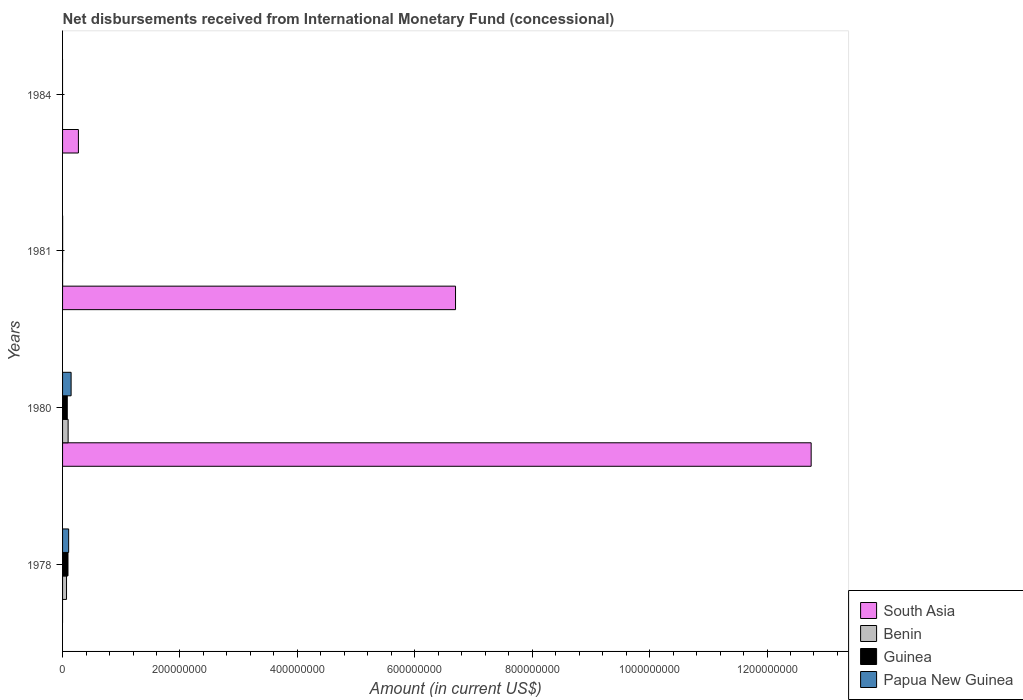How many different coloured bars are there?
Give a very brief answer. 4. Are the number of bars on each tick of the Y-axis equal?
Your response must be concise. No. How many bars are there on the 1st tick from the top?
Provide a succinct answer. 1. What is the label of the 3rd group of bars from the top?
Your answer should be very brief. 1980. In how many cases, is the number of bars for a given year not equal to the number of legend labels?
Your answer should be very brief. 2. What is the amount of disbursements received from International Monetary Fund in South Asia in 1981?
Offer a very short reply. 6.69e+08. Across all years, what is the maximum amount of disbursements received from International Monetary Fund in South Asia?
Give a very brief answer. 1.28e+09. In which year was the amount of disbursements received from International Monetary Fund in South Asia maximum?
Your answer should be very brief. 1980. What is the total amount of disbursements received from International Monetary Fund in Guinea in the graph?
Your response must be concise. 1.73e+07. What is the difference between the amount of disbursements received from International Monetary Fund in South Asia in 1980 and that in 1984?
Offer a terse response. 1.25e+09. What is the difference between the amount of disbursements received from International Monetary Fund in Papua New Guinea in 1980 and the amount of disbursements received from International Monetary Fund in Guinea in 1978?
Ensure brevity in your answer.  5.31e+06. What is the average amount of disbursements received from International Monetary Fund in Benin per year?
Your answer should be compact. 4.07e+06. In the year 1980, what is the difference between the amount of disbursements received from International Monetary Fund in Benin and amount of disbursements received from International Monetary Fund in Guinea?
Ensure brevity in your answer.  1.46e+06. What is the ratio of the amount of disbursements received from International Monetary Fund in Papua New Guinea in 1978 to that in 1981?
Your answer should be compact. 115.34. Is the amount of disbursements received from International Monetary Fund in Benin in 1980 less than that in 1981?
Your response must be concise. No. Is the difference between the amount of disbursements received from International Monetary Fund in Benin in 1978 and 1980 greater than the difference between the amount of disbursements received from International Monetary Fund in Guinea in 1978 and 1980?
Your response must be concise. No. What is the difference between the highest and the second highest amount of disbursements received from International Monetary Fund in South Asia?
Your answer should be compact. 6.06e+08. What is the difference between the highest and the lowest amount of disbursements received from International Monetary Fund in Papua New Guinea?
Your answer should be very brief. 1.46e+07. Are all the bars in the graph horizontal?
Provide a succinct answer. Yes. What is the difference between two consecutive major ticks on the X-axis?
Make the answer very short. 2.00e+08. Are the values on the major ticks of X-axis written in scientific E-notation?
Provide a short and direct response. No. Does the graph contain any zero values?
Your response must be concise. Yes. Does the graph contain grids?
Make the answer very short. No. How many legend labels are there?
Provide a short and direct response. 4. What is the title of the graph?
Keep it short and to the point. Net disbursements received from International Monetary Fund (concessional). What is the label or title of the X-axis?
Your answer should be compact. Amount (in current US$). What is the Amount (in current US$) in South Asia in 1978?
Your response must be concise. 0. What is the Amount (in current US$) in Benin in 1978?
Ensure brevity in your answer.  6.75e+06. What is the Amount (in current US$) of Guinea in 1978?
Your response must be concise. 9.24e+06. What is the Amount (in current US$) of Papua New Guinea in 1978?
Offer a very short reply. 1.04e+07. What is the Amount (in current US$) in South Asia in 1980?
Make the answer very short. 1.28e+09. What is the Amount (in current US$) of Benin in 1980?
Your answer should be very brief. 9.46e+06. What is the Amount (in current US$) in Guinea in 1980?
Give a very brief answer. 8.00e+06. What is the Amount (in current US$) in Papua New Guinea in 1980?
Your response must be concise. 1.46e+07. What is the Amount (in current US$) in South Asia in 1981?
Provide a succinct answer. 6.69e+08. What is the Amount (in current US$) of Benin in 1981?
Your response must be concise. 5.80e+04. What is the Amount (in current US$) of Guinea in 1981?
Keep it short and to the point. 1.07e+05. What is the Amount (in current US$) of Papua New Guinea in 1981?
Your answer should be very brief. 9.00e+04. What is the Amount (in current US$) in South Asia in 1984?
Ensure brevity in your answer.  2.70e+07. What is the Amount (in current US$) of Guinea in 1984?
Your response must be concise. 0. Across all years, what is the maximum Amount (in current US$) of South Asia?
Your response must be concise. 1.28e+09. Across all years, what is the maximum Amount (in current US$) in Benin?
Your answer should be compact. 9.46e+06. Across all years, what is the maximum Amount (in current US$) of Guinea?
Your response must be concise. 9.24e+06. Across all years, what is the maximum Amount (in current US$) of Papua New Guinea?
Offer a terse response. 1.46e+07. Across all years, what is the minimum Amount (in current US$) in South Asia?
Offer a terse response. 0. Across all years, what is the minimum Amount (in current US$) in Benin?
Your response must be concise. 0. Across all years, what is the minimum Amount (in current US$) in Guinea?
Your response must be concise. 0. Across all years, what is the minimum Amount (in current US$) of Papua New Guinea?
Offer a terse response. 0. What is the total Amount (in current US$) of South Asia in the graph?
Keep it short and to the point. 1.97e+09. What is the total Amount (in current US$) in Benin in the graph?
Your answer should be very brief. 1.63e+07. What is the total Amount (in current US$) of Guinea in the graph?
Ensure brevity in your answer.  1.73e+07. What is the total Amount (in current US$) of Papua New Guinea in the graph?
Offer a terse response. 2.50e+07. What is the difference between the Amount (in current US$) in Benin in 1978 and that in 1980?
Offer a terse response. -2.71e+06. What is the difference between the Amount (in current US$) in Guinea in 1978 and that in 1980?
Provide a succinct answer. 1.24e+06. What is the difference between the Amount (in current US$) in Papua New Guinea in 1978 and that in 1980?
Offer a very short reply. -4.17e+06. What is the difference between the Amount (in current US$) of Benin in 1978 and that in 1981?
Keep it short and to the point. 6.69e+06. What is the difference between the Amount (in current US$) of Guinea in 1978 and that in 1981?
Make the answer very short. 9.13e+06. What is the difference between the Amount (in current US$) of Papua New Guinea in 1978 and that in 1981?
Offer a terse response. 1.03e+07. What is the difference between the Amount (in current US$) of South Asia in 1980 and that in 1981?
Provide a succinct answer. 6.06e+08. What is the difference between the Amount (in current US$) of Benin in 1980 and that in 1981?
Your response must be concise. 9.40e+06. What is the difference between the Amount (in current US$) of Guinea in 1980 and that in 1981?
Provide a succinct answer. 7.89e+06. What is the difference between the Amount (in current US$) of Papua New Guinea in 1980 and that in 1981?
Make the answer very short. 1.45e+07. What is the difference between the Amount (in current US$) of South Asia in 1980 and that in 1984?
Give a very brief answer. 1.25e+09. What is the difference between the Amount (in current US$) of South Asia in 1981 and that in 1984?
Offer a terse response. 6.42e+08. What is the difference between the Amount (in current US$) in Benin in 1978 and the Amount (in current US$) in Guinea in 1980?
Provide a succinct answer. -1.25e+06. What is the difference between the Amount (in current US$) in Benin in 1978 and the Amount (in current US$) in Papua New Guinea in 1980?
Provide a succinct answer. -7.80e+06. What is the difference between the Amount (in current US$) of Guinea in 1978 and the Amount (in current US$) of Papua New Guinea in 1980?
Give a very brief answer. -5.31e+06. What is the difference between the Amount (in current US$) in Benin in 1978 and the Amount (in current US$) in Guinea in 1981?
Give a very brief answer. 6.64e+06. What is the difference between the Amount (in current US$) in Benin in 1978 and the Amount (in current US$) in Papua New Guinea in 1981?
Your response must be concise. 6.66e+06. What is the difference between the Amount (in current US$) in Guinea in 1978 and the Amount (in current US$) in Papua New Guinea in 1981?
Your answer should be very brief. 9.15e+06. What is the difference between the Amount (in current US$) in South Asia in 1980 and the Amount (in current US$) in Benin in 1981?
Offer a terse response. 1.28e+09. What is the difference between the Amount (in current US$) in South Asia in 1980 and the Amount (in current US$) in Guinea in 1981?
Your response must be concise. 1.28e+09. What is the difference between the Amount (in current US$) of South Asia in 1980 and the Amount (in current US$) of Papua New Guinea in 1981?
Offer a terse response. 1.28e+09. What is the difference between the Amount (in current US$) of Benin in 1980 and the Amount (in current US$) of Guinea in 1981?
Give a very brief answer. 9.35e+06. What is the difference between the Amount (in current US$) in Benin in 1980 and the Amount (in current US$) in Papua New Guinea in 1981?
Provide a succinct answer. 9.37e+06. What is the difference between the Amount (in current US$) in Guinea in 1980 and the Amount (in current US$) in Papua New Guinea in 1981?
Offer a very short reply. 7.91e+06. What is the average Amount (in current US$) in South Asia per year?
Your response must be concise. 4.93e+08. What is the average Amount (in current US$) in Benin per year?
Ensure brevity in your answer.  4.07e+06. What is the average Amount (in current US$) of Guinea per year?
Provide a succinct answer. 4.34e+06. What is the average Amount (in current US$) in Papua New Guinea per year?
Ensure brevity in your answer.  6.26e+06. In the year 1978, what is the difference between the Amount (in current US$) in Benin and Amount (in current US$) in Guinea?
Keep it short and to the point. -2.49e+06. In the year 1978, what is the difference between the Amount (in current US$) in Benin and Amount (in current US$) in Papua New Guinea?
Your answer should be compact. -3.63e+06. In the year 1978, what is the difference between the Amount (in current US$) of Guinea and Amount (in current US$) of Papua New Guinea?
Offer a terse response. -1.14e+06. In the year 1980, what is the difference between the Amount (in current US$) of South Asia and Amount (in current US$) of Benin?
Your answer should be very brief. 1.27e+09. In the year 1980, what is the difference between the Amount (in current US$) of South Asia and Amount (in current US$) of Guinea?
Offer a very short reply. 1.27e+09. In the year 1980, what is the difference between the Amount (in current US$) of South Asia and Amount (in current US$) of Papua New Guinea?
Your answer should be compact. 1.26e+09. In the year 1980, what is the difference between the Amount (in current US$) of Benin and Amount (in current US$) of Guinea?
Ensure brevity in your answer.  1.46e+06. In the year 1980, what is the difference between the Amount (in current US$) of Benin and Amount (in current US$) of Papua New Guinea?
Your response must be concise. -5.09e+06. In the year 1980, what is the difference between the Amount (in current US$) of Guinea and Amount (in current US$) of Papua New Guinea?
Give a very brief answer. -6.56e+06. In the year 1981, what is the difference between the Amount (in current US$) of South Asia and Amount (in current US$) of Benin?
Your response must be concise. 6.69e+08. In the year 1981, what is the difference between the Amount (in current US$) in South Asia and Amount (in current US$) in Guinea?
Offer a terse response. 6.69e+08. In the year 1981, what is the difference between the Amount (in current US$) of South Asia and Amount (in current US$) of Papua New Guinea?
Offer a terse response. 6.69e+08. In the year 1981, what is the difference between the Amount (in current US$) in Benin and Amount (in current US$) in Guinea?
Your response must be concise. -4.90e+04. In the year 1981, what is the difference between the Amount (in current US$) of Benin and Amount (in current US$) of Papua New Guinea?
Keep it short and to the point. -3.20e+04. In the year 1981, what is the difference between the Amount (in current US$) of Guinea and Amount (in current US$) of Papua New Guinea?
Make the answer very short. 1.70e+04. What is the ratio of the Amount (in current US$) of Benin in 1978 to that in 1980?
Your answer should be very brief. 0.71. What is the ratio of the Amount (in current US$) of Guinea in 1978 to that in 1980?
Provide a short and direct response. 1.16. What is the ratio of the Amount (in current US$) in Papua New Guinea in 1978 to that in 1980?
Keep it short and to the point. 0.71. What is the ratio of the Amount (in current US$) in Benin in 1978 to that in 1981?
Provide a short and direct response. 116.34. What is the ratio of the Amount (in current US$) of Guinea in 1978 to that in 1981?
Ensure brevity in your answer.  86.36. What is the ratio of the Amount (in current US$) of Papua New Guinea in 1978 to that in 1981?
Make the answer very short. 115.34. What is the ratio of the Amount (in current US$) of South Asia in 1980 to that in 1981?
Your answer should be compact. 1.91. What is the ratio of the Amount (in current US$) of Benin in 1980 to that in 1981?
Offer a terse response. 163.09. What is the ratio of the Amount (in current US$) in Guinea in 1980 to that in 1981?
Your response must be concise. 74.74. What is the ratio of the Amount (in current US$) of Papua New Guinea in 1980 to that in 1981?
Keep it short and to the point. 161.69. What is the ratio of the Amount (in current US$) in South Asia in 1980 to that in 1984?
Offer a terse response. 47.27. What is the ratio of the Amount (in current US$) of South Asia in 1981 to that in 1984?
Keep it short and to the point. 24.81. What is the difference between the highest and the second highest Amount (in current US$) in South Asia?
Ensure brevity in your answer.  6.06e+08. What is the difference between the highest and the second highest Amount (in current US$) of Benin?
Give a very brief answer. 2.71e+06. What is the difference between the highest and the second highest Amount (in current US$) in Guinea?
Offer a terse response. 1.24e+06. What is the difference between the highest and the second highest Amount (in current US$) in Papua New Guinea?
Make the answer very short. 4.17e+06. What is the difference between the highest and the lowest Amount (in current US$) of South Asia?
Provide a succinct answer. 1.28e+09. What is the difference between the highest and the lowest Amount (in current US$) in Benin?
Provide a short and direct response. 9.46e+06. What is the difference between the highest and the lowest Amount (in current US$) of Guinea?
Your answer should be very brief. 9.24e+06. What is the difference between the highest and the lowest Amount (in current US$) of Papua New Guinea?
Your response must be concise. 1.46e+07. 